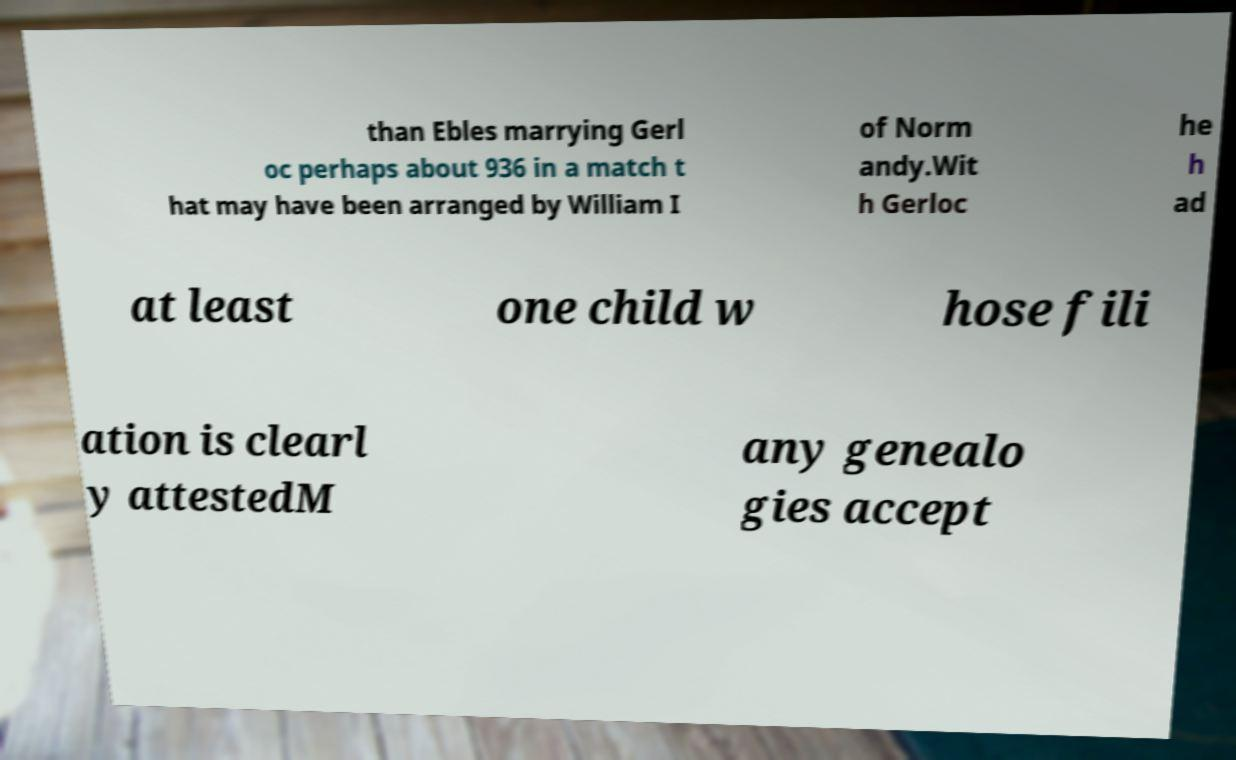Please identify and transcribe the text found in this image. than Ebles marrying Gerl oc perhaps about 936 in a match t hat may have been arranged by William I of Norm andy.Wit h Gerloc he h ad at least one child w hose fili ation is clearl y attestedM any genealo gies accept 